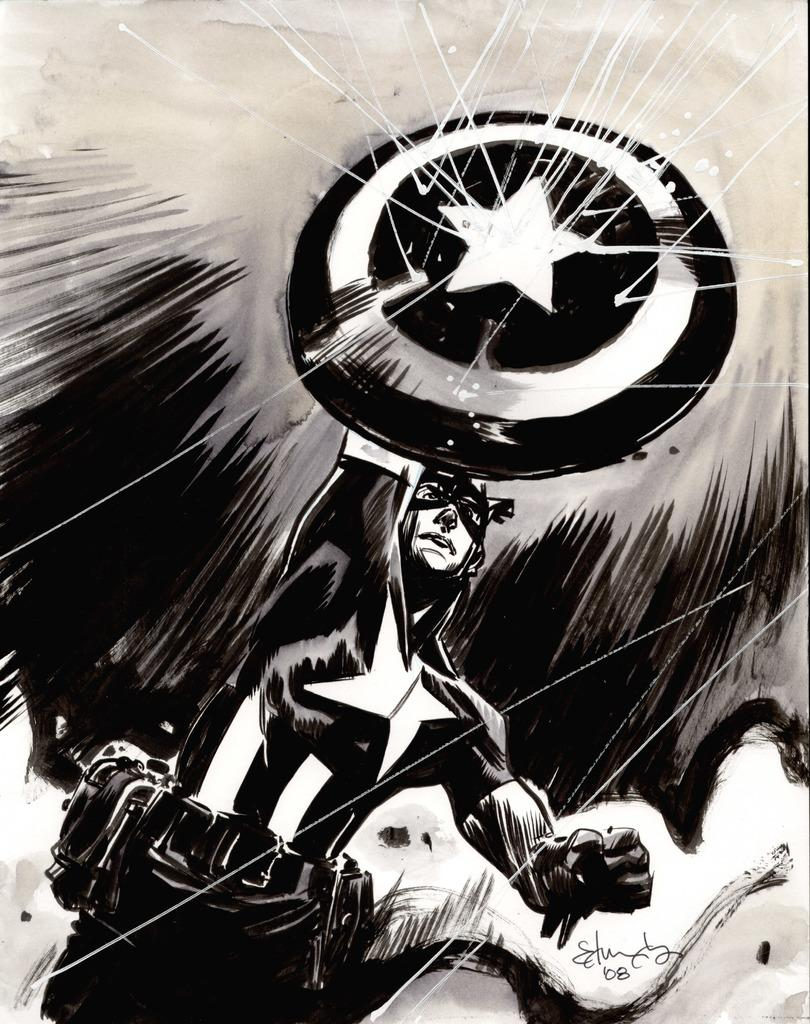What is the main subject in the foreground of the image? There is a man in the foreground of the image. What is the man wearing on his hands? The man is wearing gloves. What is the man wearing on his face? The man is wearing a mask. What object is the man holding in the image? The man is holding a shield. What is happening to the shield in the image? There are rays hitting the shield. How many frogs are sitting on the man's shirt in the image? There are no frogs present in the image, and the man is not wearing a shirt. 